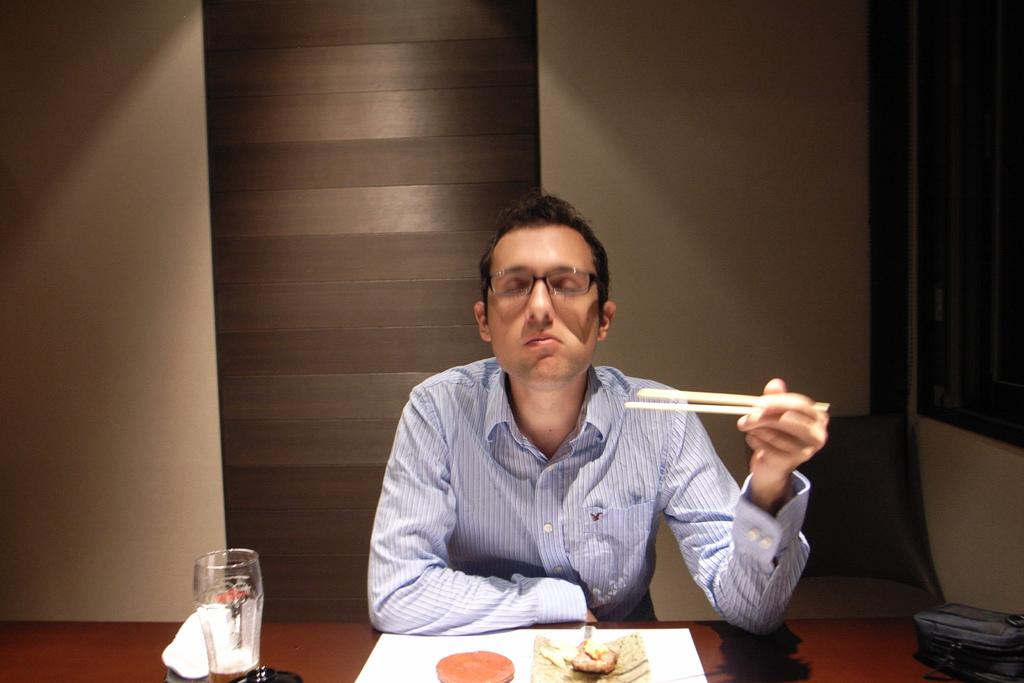What is the man in the image doing? The man is sitting in the image. What is on the table in the image? There is food and a glass on a table in the image. What can be seen in the background of the image? There is a wall visible in the background of the image. Are there any fairies flying around the man in the image? No, there are no fairies present in the image. What type of crate is visible on the table in the image? There is no crate visible on the table in the image. 